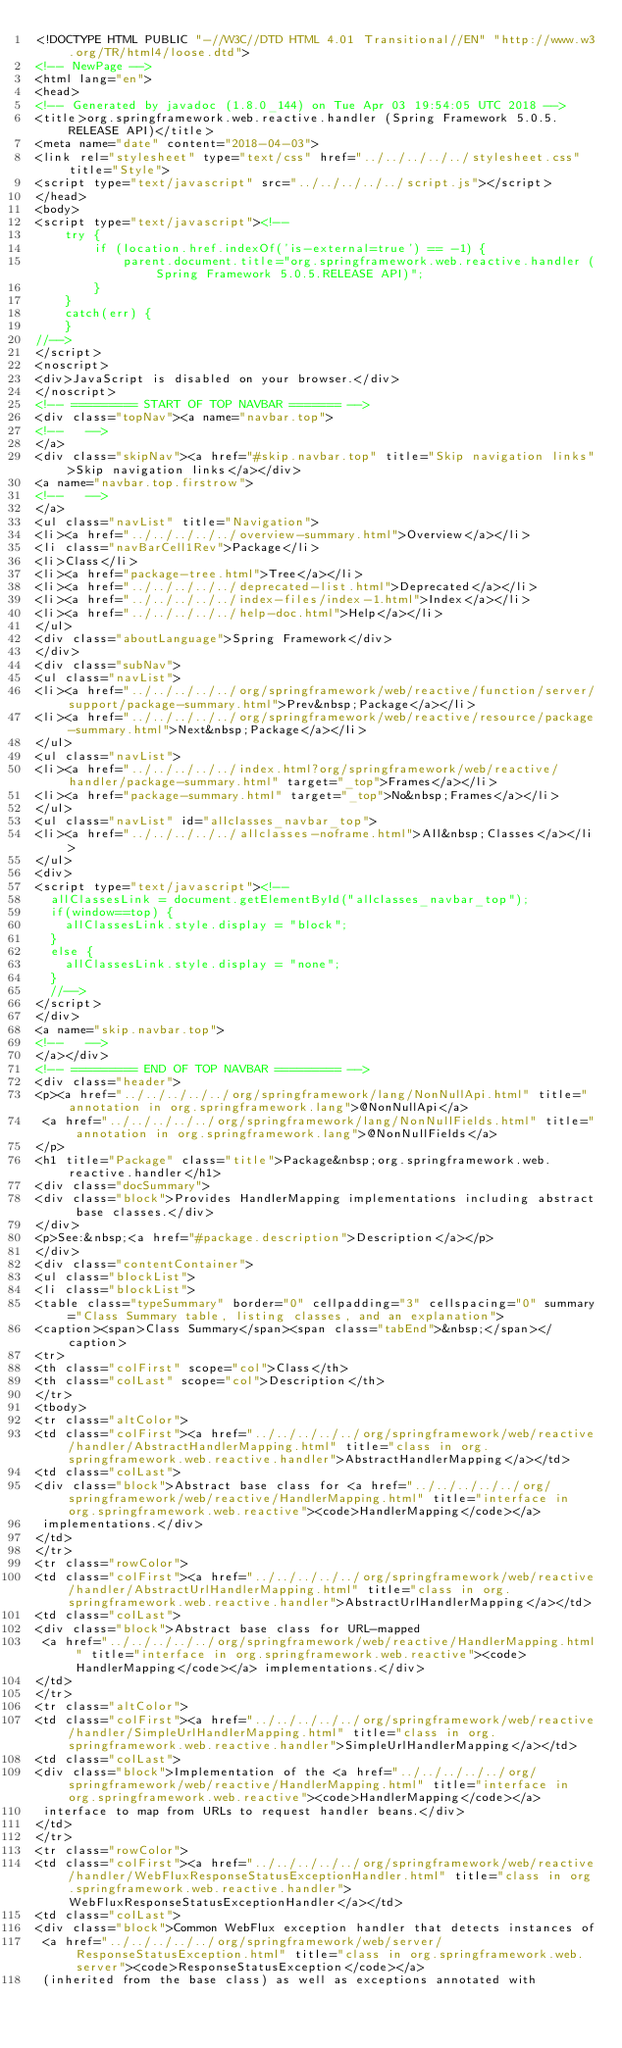Convert code to text. <code><loc_0><loc_0><loc_500><loc_500><_HTML_><!DOCTYPE HTML PUBLIC "-//W3C//DTD HTML 4.01 Transitional//EN" "http://www.w3.org/TR/html4/loose.dtd">
<!-- NewPage -->
<html lang="en">
<head>
<!-- Generated by javadoc (1.8.0_144) on Tue Apr 03 19:54:05 UTC 2018 -->
<title>org.springframework.web.reactive.handler (Spring Framework 5.0.5.RELEASE API)</title>
<meta name="date" content="2018-04-03">
<link rel="stylesheet" type="text/css" href="../../../../../stylesheet.css" title="Style">
<script type="text/javascript" src="../../../../../script.js"></script>
</head>
<body>
<script type="text/javascript"><!--
    try {
        if (location.href.indexOf('is-external=true') == -1) {
            parent.document.title="org.springframework.web.reactive.handler (Spring Framework 5.0.5.RELEASE API)";
        }
    }
    catch(err) {
    }
//-->
</script>
<noscript>
<div>JavaScript is disabled on your browser.</div>
</noscript>
<!-- ========= START OF TOP NAVBAR ======= -->
<div class="topNav"><a name="navbar.top">
<!--   -->
</a>
<div class="skipNav"><a href="#skip.navbar.top" title="Skip navigation links">Skip navigation links</a></div>
<a name="navbar.top.firstrow">
<!--   -->
</a>
<ul class="navList" title="Navigation">
<li><a href="../../../../../overview-summary.html">Overview</a></li>
<li class="navBarCell1Rev">Package</li>
<li>Class</li>
<li><a href="package-tree.html">Tree</a></li>
<li><a href="../../../../../deprecated-list.html">Deprecated</a></li>
<li><a href="../../../../../index-files/index-1.html">Index</a></li>
<li><a href="../../../../../help-doc.html">Help</a></li>
</ul>
<div class="aboutLanguage">Spring Framework</div>
</div>
<div class="subNav">
<ul class="navList">
<li><a href="../../../../../org/springframework/web/reactive/function/server/support/package-summary.html">Prev&nbsp;Package</a></li>
<li><a href="../../../../../org/springframework/web/reactive/resource/package-summary.html">Next&nbsp;Package</a></li>
</ul>
<ul class="navList">
<li><a href="../../../../../index.html?org/springframework/web/reactive/handler/package-summary.html" target="_top">Frames</a></li>
<li><a href="package-summary.html" target="_top">No&nbsp;Frames</a></li>
</ul>
<ul class="navList" id="allclasses_navbar_top">
<li><a href="../../../../../allclasses-noframe.html">All&nbsp;Classes</a></li>
</ul>
<div>
<script type="text/javascript"><!--
  allClassesLink = document.getElementById("allclasses_navbar_top");
  if(window==top) {
    allClassesLink.style.display = "block";
  }
  else {
    allClassesLink.style.display = "none";
  }
  //-->
</script>
</div>
<a name="skip.navbar.top">
<!--   -->
</a></div>
<!-- ========= END OF TOP NAVBAR ========= -->
<div class="header">
<p><a href="../../../../../org/springframework/lang/NonNullApi.html" title="annotation in org.springframework.lang">@NonNullApi</a>
 <a href="../../../../../org/springframework/lang/NonNullFields.html" title="annotation in org.springframework.lang">@NonNullFields</a>
</p>
<h1 title="Package" class="title">Package&nbsp;org.springframework.web.reactive.handler</h1>
<div class="docSummary">
<div class="block">Provides HandlerMapping implementations including abstract base classes.</div>
</div>
<p>See:&nbsp;<a href="#package.description">Description</a></p>
</div>
<div class="contentContainer">
<ul class="blockList">
<li class="blockList">
<table class="typeSummary" border="0" cellpadding="3" cellspacing="0" summary="Class Summary table, listing classes, and an explanation">
<caption><span>Class Summary</span><span class="tabEnd">&nbsp;</span></caption>
<tr>
<th class="colFirst" scope="col">Class</th>
<th class="colLast" scope="col">Description</th>
</tr>
<tbody>
<tr class="altColor">
<td class="colFirst"><a href="../../../../../org/springframework/web/reactive/handler/AbstractHandlerMapping.html" title="class in org.springframework.web.reactive.handler">AbstractHandlerMapping</a></td>
<td class="colLast">
<div class="block">Abstract base class for <a href="../../../../../org/springframework/web/reactive/HandlerMapping.html" title="interface in org.springframework.web.reactive"><code>HandlerMapping</code></a>
 implementations.</div>
</td>
</tr>
<tr class="rowColor">
<td class="colFirst"><a href="../../../../../org/springframework/web/reactive/handler/AbstractUrlHandlerMapping.html" title="class in org.springframework.web.reactive.handler">AbstractUrlHandlerMapping</a></td>
<td class="colLast">
<div class="block">Abstract base class for URL-mapped
 <a href="../../../../../org/springframework/web/reactive/HandlerMapping.html" title="interface in org.springframework.web.reactive"><code>HandlerMapping</code></a> implementations.</div>
</td>
</tr>
<tr class="altColor">
<td class="colFirst"><a href="../../../../../org/springframework/web/reactive/handler/SimpleUrlHandlerMapping.html" title="class in org.springframework.web.reactive.handler">SimpleUrlHandlerMapping</a></td>
<td class="colLast">
<div class="block">Implementation of the <a href="../../../../../org/springframework/web/reactive/HandlerMapping.html" title="interface in org.springframework.web.reactive"><code>HandlerMapping</code></a>
 interface to map from URLs to request handler beans.</div>
</td>
</tr>
<tr class="rowColor">
<td class="colFirst"><a href="../../../../../org/springframework/web/reactive/handler/WebFluxResponseStatusExceptionHandler.html" title="class in org.springframework.web.reactive.handler">WebFluxResponseStatusExceptionHandler</a></td>
<td class="colLast">
<div class="block">Common WebFlux exception handler that detects instances of
 <a href="../../../../../org/springframework/web/server/ResponseStatusException.html" title="class in org.springframework.web.server"><code>ResponseStatusException</code></a>
 (inherited from the base class) as well as exceptions annotated with</code> 